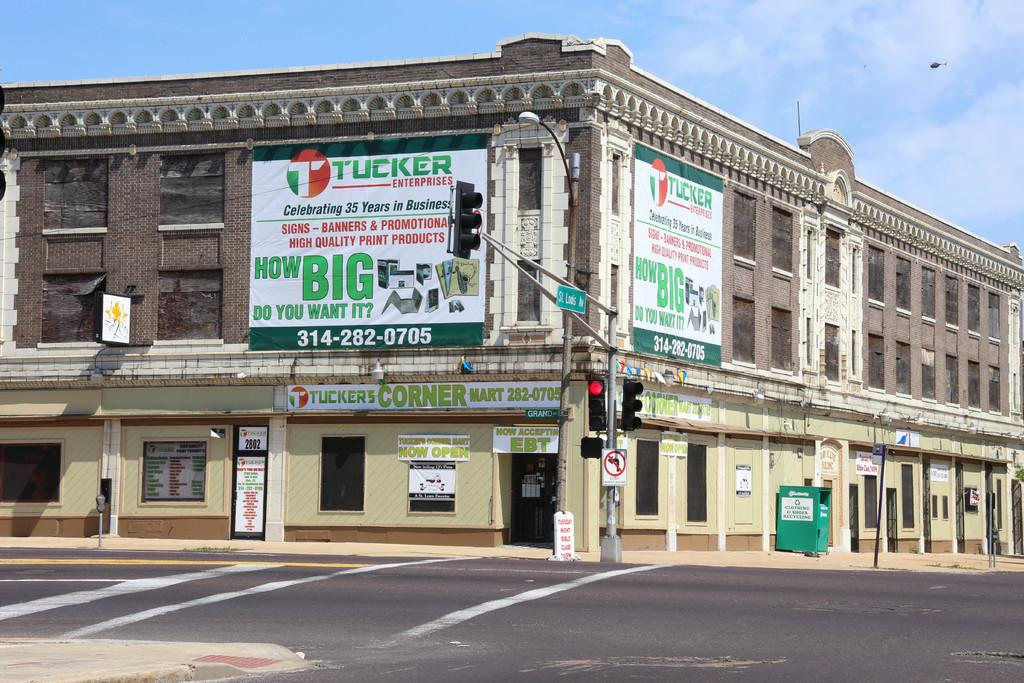What type of structure is in the image? There is a building in the image. What is on the building? The building has posters on it. What is on the ground in the image? There is a road in the image. What is on the road? A traffic pole is present on the road. What is visible in the background of the image? The sky is visible in the image. What is flying in the sky? There is a helicopter in the sky. What type of wrench is being used to fix the helicopter in the image? There is no wrench or any indication of repair work being done on the helicopter in the image. What religious symbol can be seen on the building in the image? There is no religious symbol visible on the building in the image. 